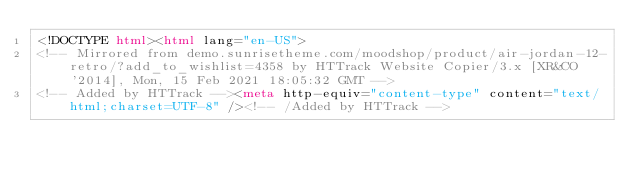Convert code to text. <code><loc_0><loc_0><loc_500><loc_500><_HTML_><!DOCTYPE html><html lang="en-US">
<!-- Mirrored from demo.sunrisetheme.com/moodshop/product/air-jordan-12-retro/?add_to_wishlist=4358 by HTTrack Website Copier/3.x [XR&CO'2014], Mon, 15 Feb 2021 18:05:32 GMT -->
<!-- Added by HTTrack --><meta http-equiv="content-type" content="text/html;charset=UTF-8" /><!-- /Added by HTTrack --></code> 